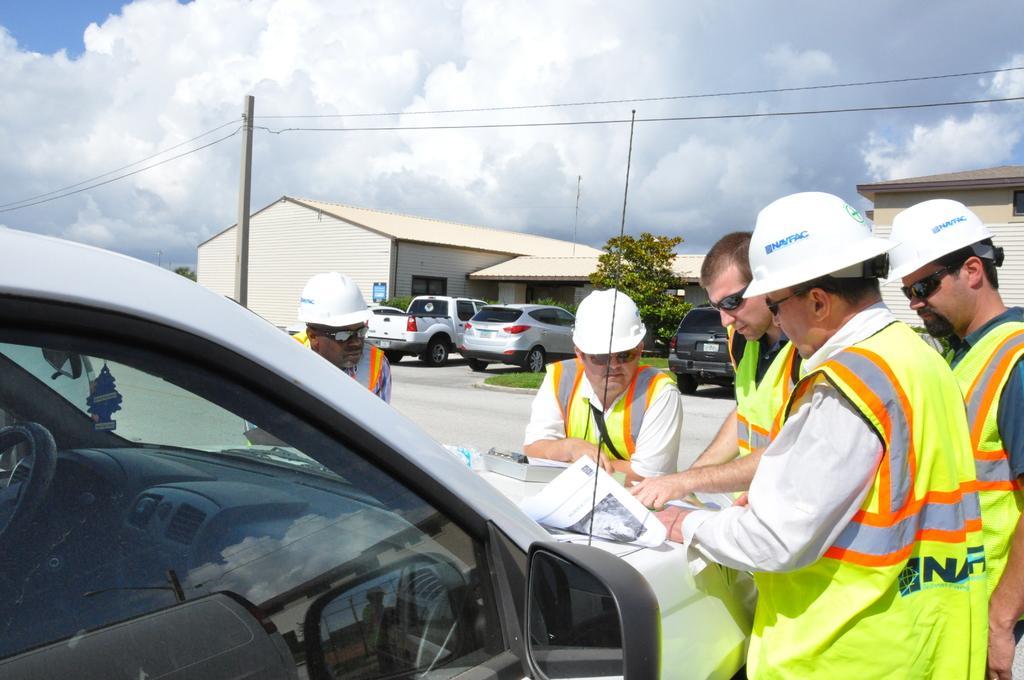Could you give a brief overview of what you see in this image? In the foreground of this image, there are few men standing near a vehicle on which books, papers, and a bottle is placed. In the background, there are houses, trees, vehicles, poles, cables, sky and the cloud. 